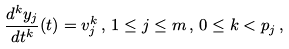<formula> <loc_0><loc_0><loc_500><loc_500>\frac { d ^ { k } y _ { j } } { d t ^ { k } } ( t ) = v _ { j } ^ { k } \, , \, 1 \leq j \leq m \, , \, 0 \leq k < p _ { j } \, ,</formula> 